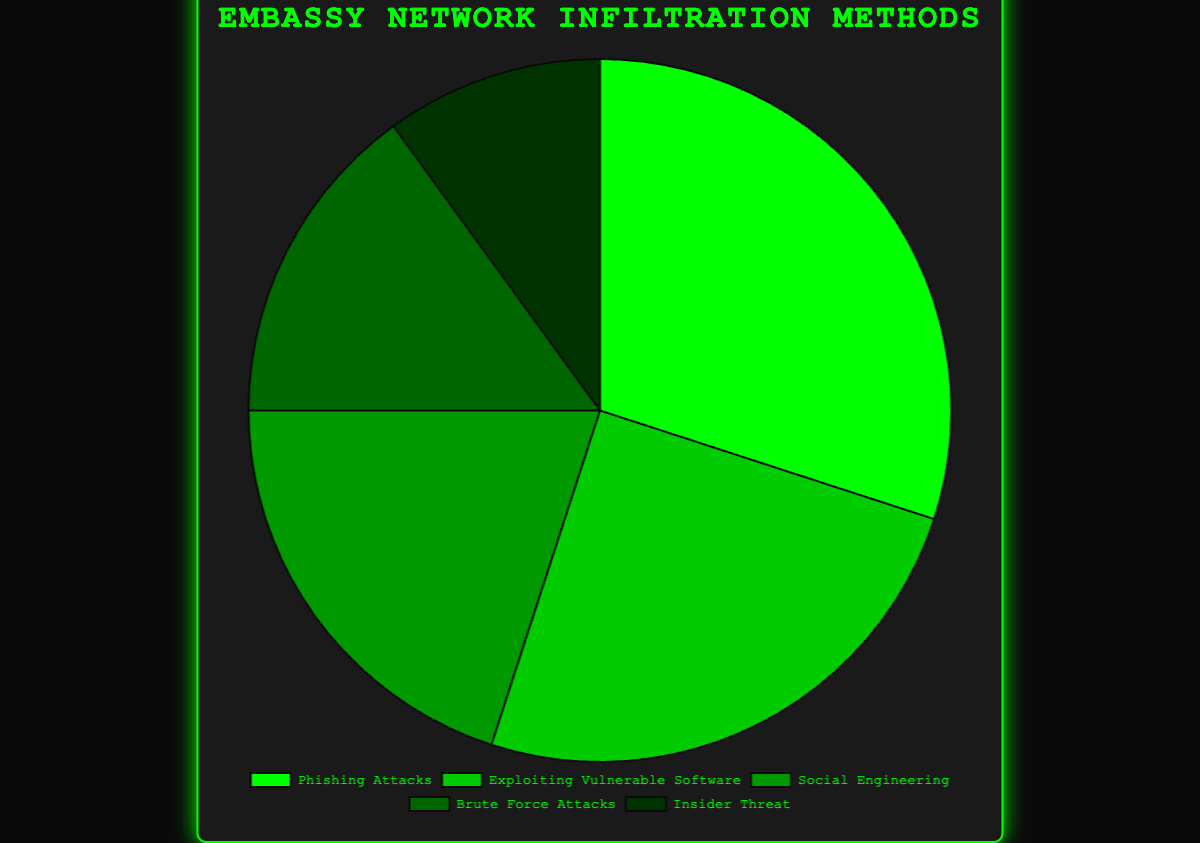Which method is used the most to infiltrate embassy networks? The method with the highest percentage in the pie chart is "Phishing Attacks" with 30%.
Answer: Phishing Attacks What's the difference in percentage points between "Phishing Attacks" and "Social Engineering"? The percentage for "Phishing Attacks" is 30%, and for "Social Engineering," it's 20%. The difference is 30 - 20 = 10 percentage points.
Answer: 10 percentage points If you combine the percentages for "Brute Force Attacks" and "Insider Threat," what is the total? "Brute Force Attacks" is 15% and "Insider Threat" is 10%. Together, they sum up to 15 + 10 = 25%.
Answer: 25% Which method has the smallest representation in the pie chart? The method with the smallest percentage in the pie chart is "Insider Threat" with 10%.
Answer: Insider Threat How many methods have a percentage greater than or equal to 20%? The methods that are greater than or equal to 20% are "Phishing Attacks" (30%), "Exploiting Vulnerable Software" (25%), and "Social Engineering" (20%). There are three methods.
Answer: 3 Which method has the next highest percentage after "Phishing Attacks"? After "Phishing Attacks" at 30%, the next highest percentage is for "Exploiting Vulnerable Software," which is 25%.
Answer: Exploiting Vulnerable Software What is the average percentage of all methods of entry? Summing up the percentages (30 + 25 + 20 + 15 + 10) gives 100. The average is 100 / 5 = 20%.
Answer: 20% How do "Phishing Attacks" and "Exploiting Vulnerable Software" together compare to "Social Engineering, " "Brute Force Attacks," and "Insider Threat" together? "Phishing Attacks" and "Exploiting Vulnerable Software" together sum up to 30 + 25 = 55%. "Social Engineering," "Brute Force Attacks," and "Insider Threat" together sum up to 20 + 15 + 10 = 45%. 55% is greater than 45%.
Answer: Greater What is the combined percentage for methods involving human factors ("Phishing Attacks," "Social Engineering," and "Insider Threat")? Adding the percentages for "Phishing Attacks" (30%), "Social Engineering" (20%), and "Insider Threat" (10%), we get 30 + 20 + 10 = 60%.
Answer: 60% Which two methods combined constitute exactly half of all infiltration methods by percentage? "Phishing Attacks" (30%) and "Exploiting Vulnerable Software" (25%) combined are 30 + 25, which is 55%, not half. "Social Engineering" (20%), and "Brute Force Attacks" (15%) combined are 20 + 15, which is 35%, not half. "Social Engineering" (20%) and "Insider Threat" (10%) combined are 20 + 10, which is 30% again, not half. The only correct combination is "Phishing Attacks" and "Brute Force Attacks" (30 + 15 = 45%). Therefore, no two methods when combined truly constitute exactly half. This prompts a reconsideration that perhaps the simplest analysis of individual combinations suffices.
Answer: None 